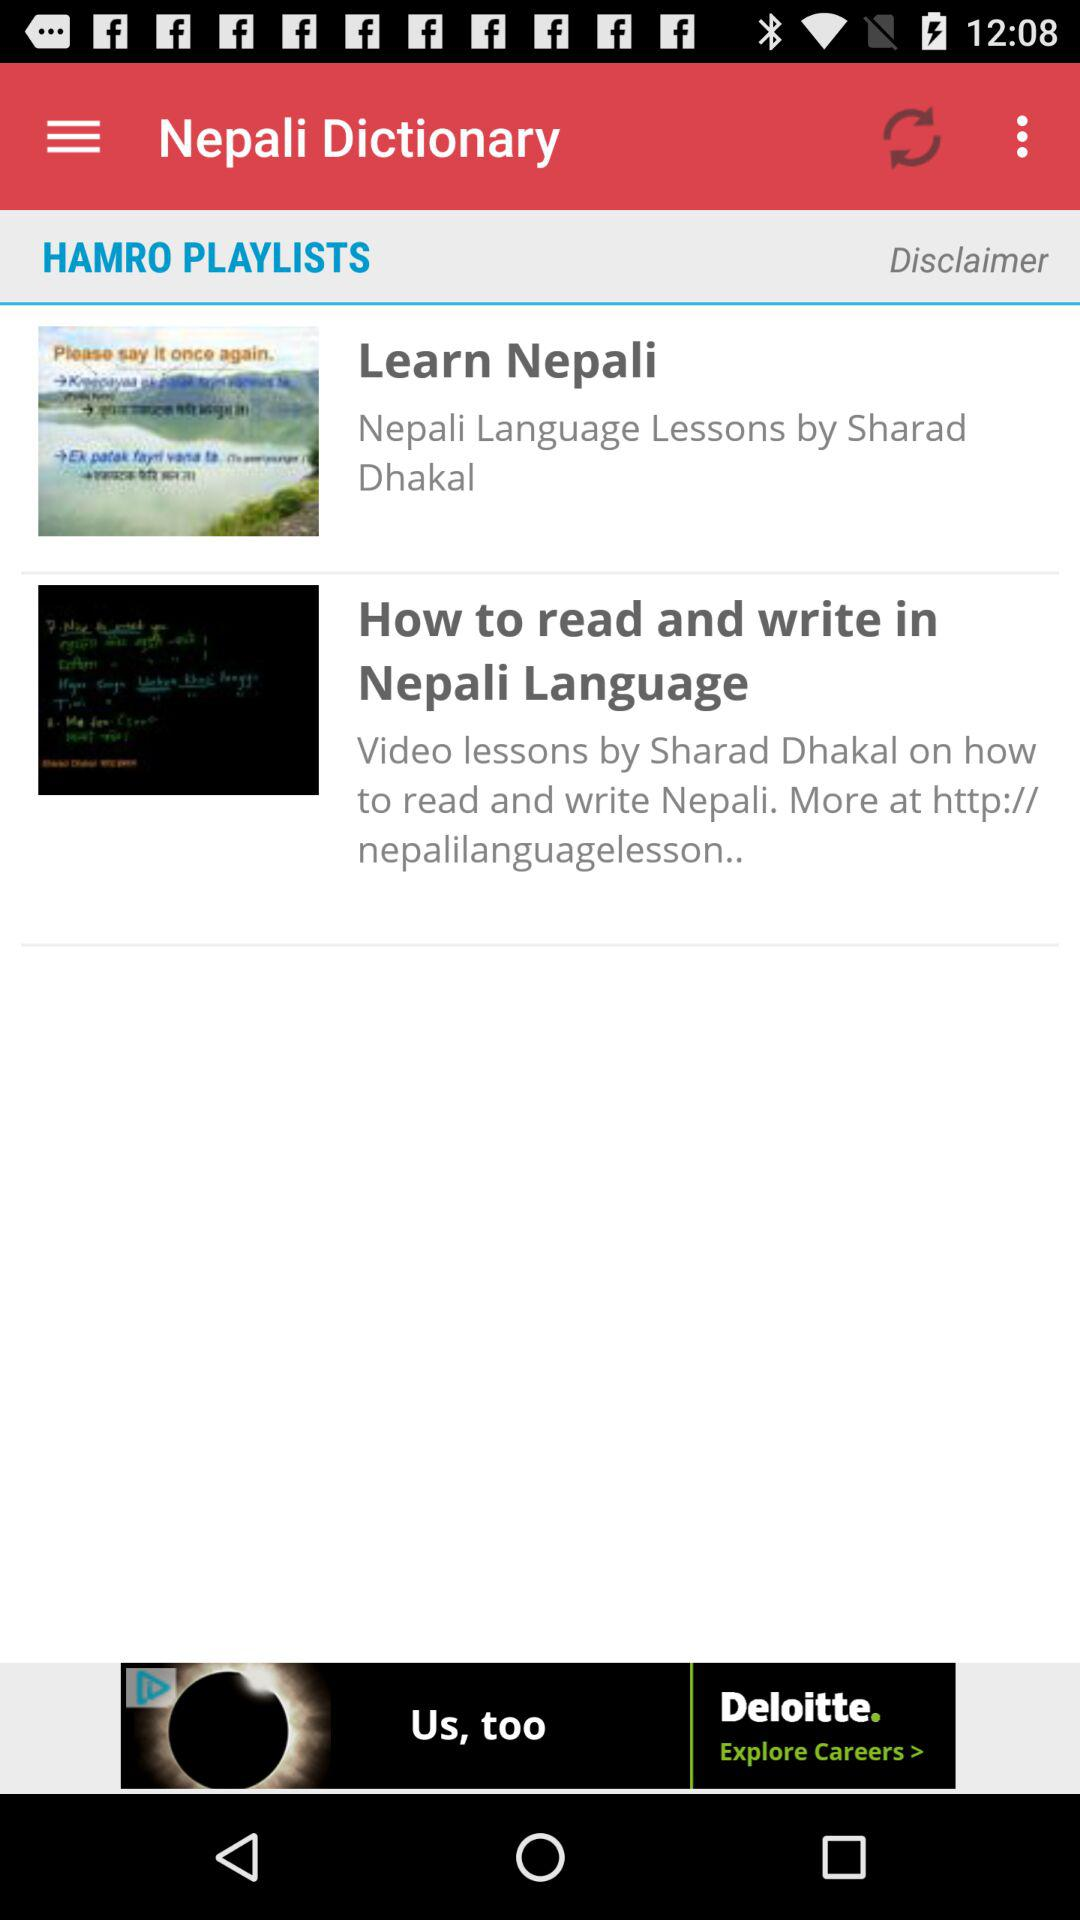On what website can we visit for more information about the Nepali language? The website that you can visit for more information about the Nepali language is "http://nepalilanguagelesson..". 